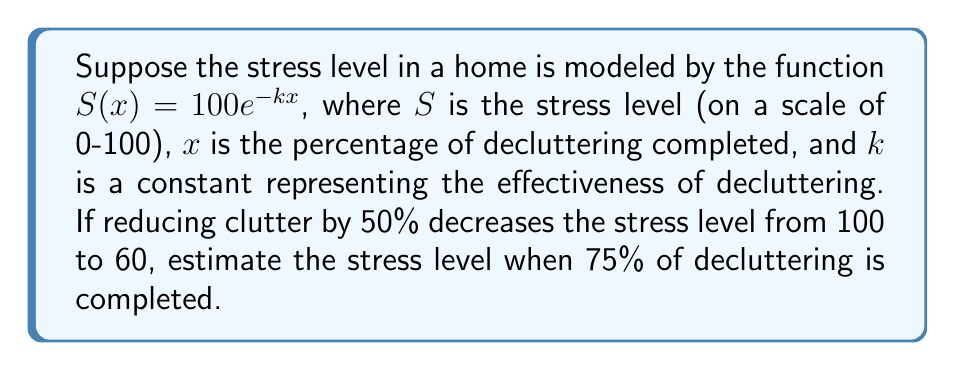Show me your answer to this math problem. 1) We start with the given function: $S(x) = 100e^{-kx}$

2) We know that when $x = 50%$ (or 0.5), $S = 60$. Let's use this to find $k$:

   $60 = 100e^{-k(0.5)}$

3) Divide both sides by 100:

   $0.6 = e^{-0.5k}$

4) Take the natural log of both sides:

   $\ln(0.6) = -0.5k$

5) Solve for $k$:

   $k = -\frac{2\ln(0.6)}{1} \approx 1.0217$

6) Now that we have $k$, we can use the original function to find $S$ when $x = 75%$ (or 0.75):

   $S(0.75) = 100e^{-1.0217(0.75)}$

7) Calculate:

   $S(0.75) = 100e^{-0.7663} \approx 46.48$

Thus, the estimated stress level when 75% of decluttering is completed is approximately 46.48.
Answer: 46.48 